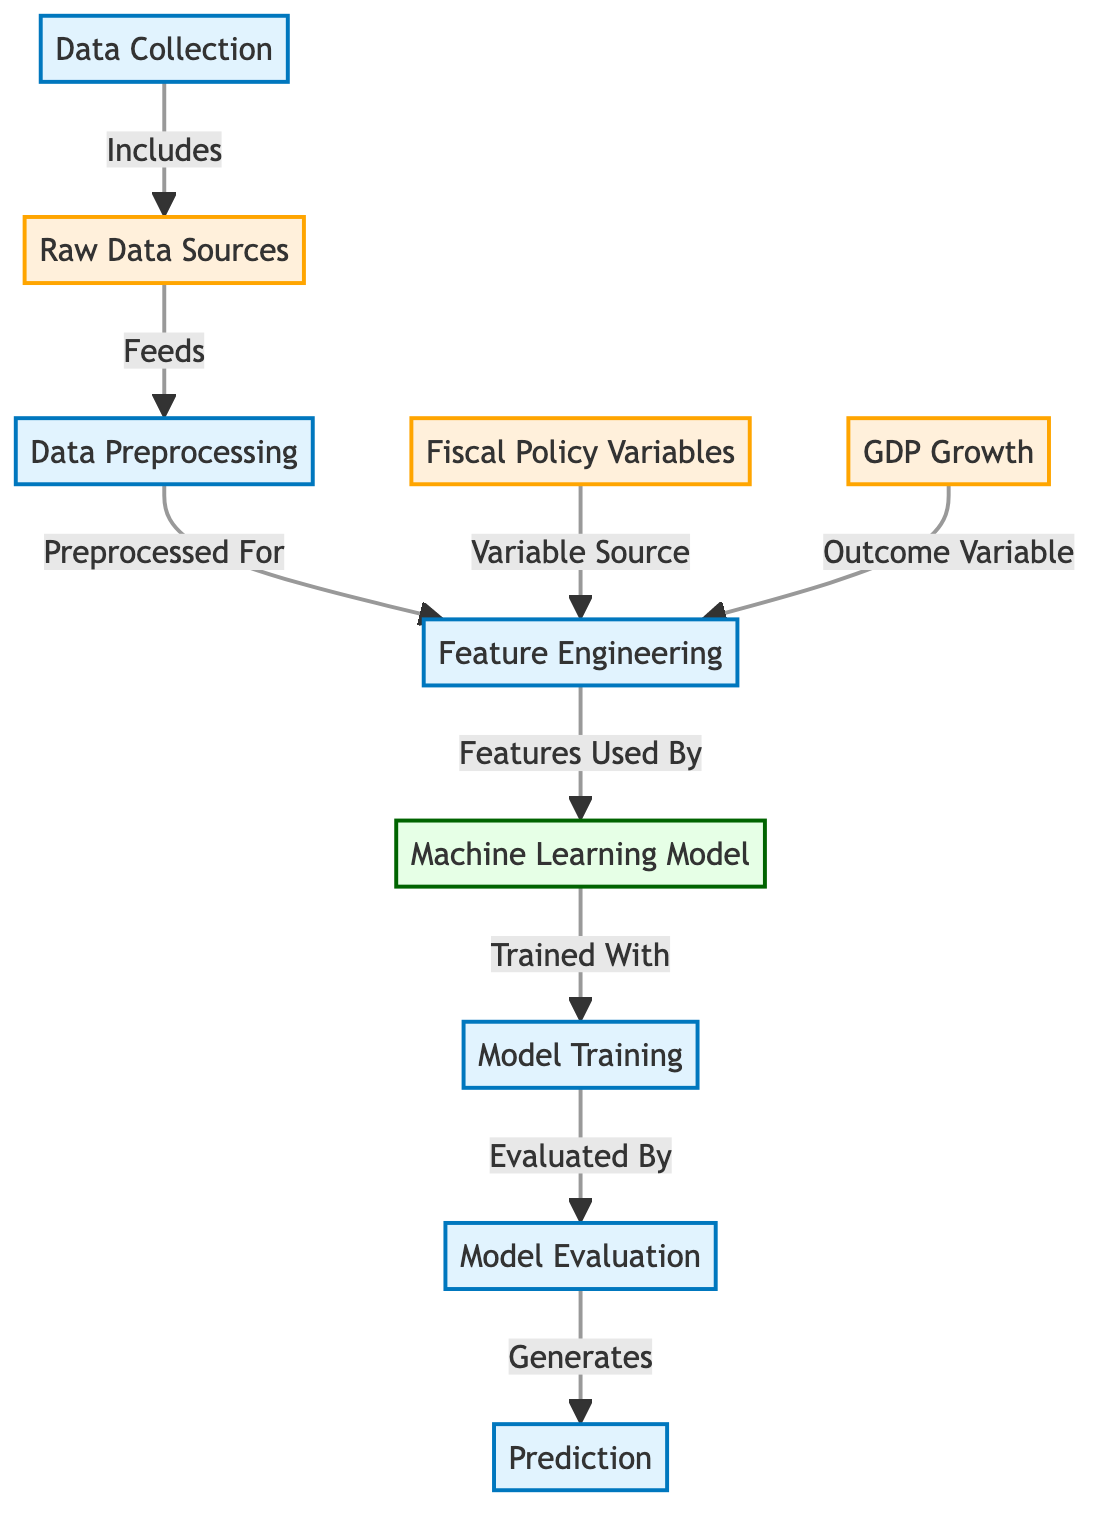What is the first step in the diagram? The first step indicated in the diagram is "Data Collection," which is an entry point for the process described. This step is connected directly to the next node, which represents raw data sources.
Answer: Data Collection How many main processes are there in the diagram? Upon counting the nodes categorized as processes, there are five key steps: Data Collection, Data Preprocessing, Feature Engineering, Model Training, and Model Evaluation.
Answer: Five What does the "Fiscal Policy Variables" node signify in the diagram? The node titled "Fiscal Policy Variables" indicates that it serves as a source of variables that will be used in Feature Engineering. It is a data node pointing towards the subsequent process.
Answer: Variable Source Which node directly leads to "Model Evaluation"? In the flow of the diagram, the node "Model Training" directly leads to the node "Model Evaluation." This indicates that evaluation occurs after the training of the machine learning model.
Answer: Model Training What is the relationship between "Feature Engineering" and "Machine Learning Model"? The diagram shows that "Feature Engineering" feeds into the "Machine Learning Model," signifying that the features developed during engineering are utilized by the model for training.
Answer: Features Used By In what order do the processes occur from data collection to prediction? The processes flow from Data Collection to Raw Data Sources, then to Data Preprocessing, followed by Feature Engineering, then to Machine Learning Model, then to Model Training, next to Model Evaluation, and finally to Prediction. By following the arrows in the diagram sequentially, this order becomes clear.
Answer: Data Collection → Raw Data Sources → Data Preprocessing → Feature Engineering → Machine Learning Model → Model Training → Model Evaluation → Prediction Which variables serve as the inputs for "Feature Engineering"? The inputs for "Feature Engineering" are indicated in the diagram as "Fiscal Policy Variables" and "GDP Growth." Both are nodes connected to this process.
Answer: Fiscal Policy Variables and GDP Growth What type of data is contained in the "Raw Data Sources"? The "Raw Data Sources" node represents unprocessed, primary data that has been collected for subsequent analysis and job processing, as shown in the diagram.
Answer: Unprocessed Data 